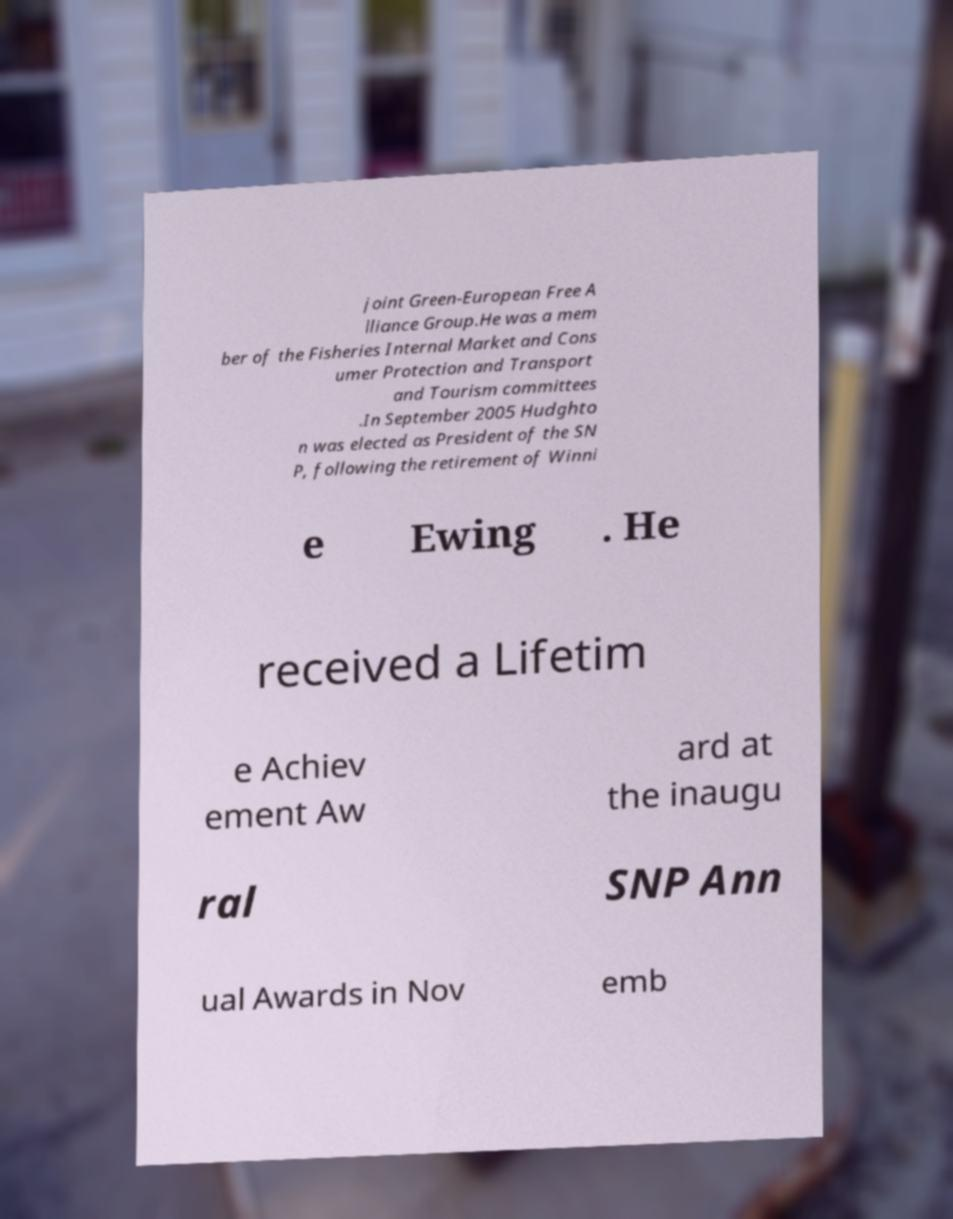Please read and relay the text visible in this image. What does it say? joint Green-European Free A lliance Group.He was a mem ber of the Fisheries Internal Market and Cons umer Protection and Transport and Tourism committees .In September 2005 Hudghto n was elected as President of the SN P, following the retirement of Winni e Ewing . He received a Lifetim e Achiev ement Aw ard at the inaugu ral SNP Ann ual Awards in Nov emb 